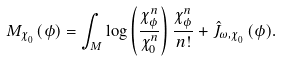<formula> <loc_0><loc_0><loc_500><loc_500>M _ { { \chi ^ { \ } _ { 0 } } } ( \phi ) = \int _ { M } \log \left ( \frac { \chi _ { \phi } ^ { n } } { { \chi ^ { n } _ { 0 } } } \right ) \frac { \chi _ { \phi } ^ { n } } { n ! } + \hat { J } _ { \omega , { \chi ^ { \ } _ { 0 } } } ( \phi ) .</formula> 